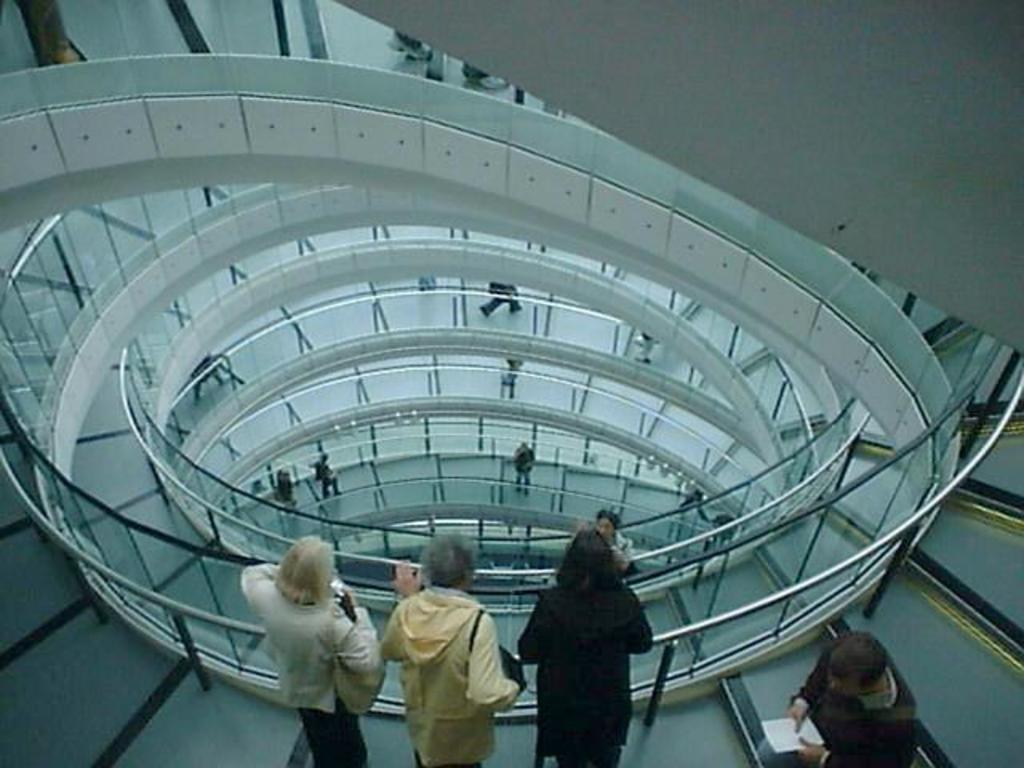How would you summarize this image in a sentence or two? In this picture I can see there is a multi storied building and there are few stairs and there is a glass railing and there is a man standing on the right bottom and he is holding a white object. There are three women standing at the railing and there are few people standing at different floors. 